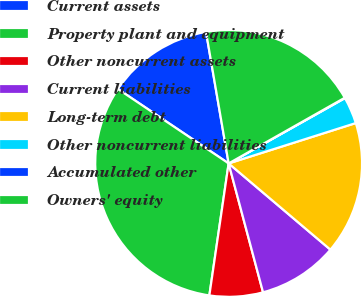Convert chart. <chart><loc_0><loc_0><loc_500><loc_500><pie_chart><fcel>Current assets<fcel>Property plant and equipment<fcel>Other noncurrent assets<fcel>Current liabilities<fcel>Long-term debt<fcel>Other noncurrent liabilities<fcel>Accumulated other<fcel>Owners' equity<nl><fcel>12.87%<fcel>32.11%<fcel>6.46%<fcel>9.66%<fcel>16.08%<fcel>3.25%<fcel>0.05%<fcel>19.52%<nl></chart> 